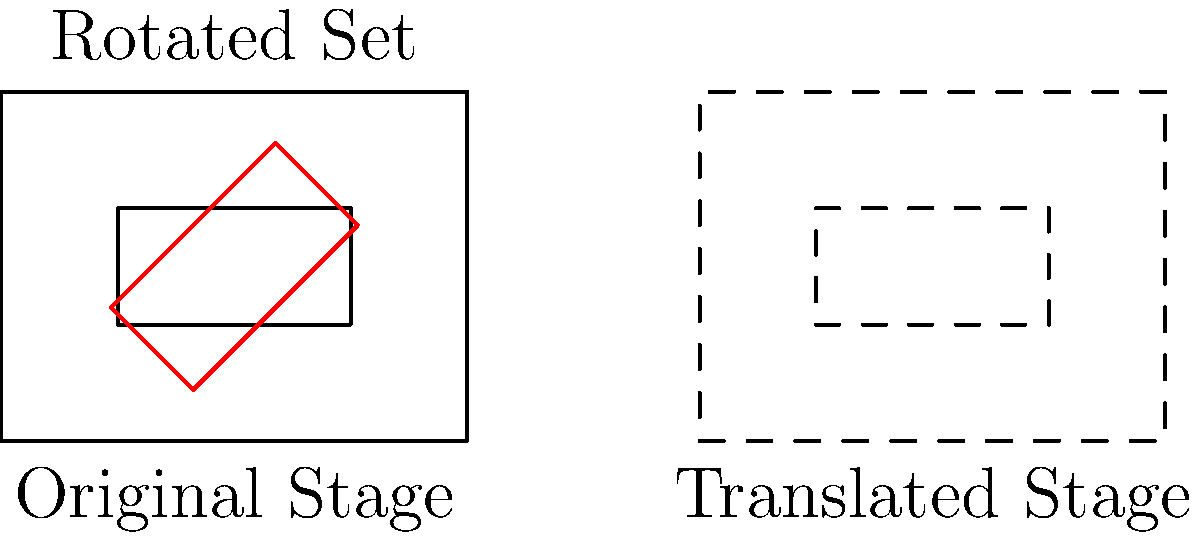In your latest theater production, you're working on a innovative stage design. The rectangular stage (represented by the outer rectangle) measures 4 units wide and 3 units high. Within it, there's a smaller rectangular set piece (the inner rectangle) that's initially positioned as shown. The stage manager wants to apply the following transformations:

1. Translate the entire stage layout 6 units to the right (shown with dashed lines).
2. Rotate the inner set piece 45 degrees clockwise around its center point.

After these transformations, what is the approximate area of overlap between the rotated inner set piece (shown in red) and the translated outer stage? Let's approach this step-by-step:

1. Original dimensions:
   - Outer stage: 4 units × 3 units
   - Inner set piece: 2 units × 1 unit

2. Translation:
   - The entire layout is moved 6 units to the right.
   - This doesn't affect the overlap calculation.

3. Rotation:
   - The inner set piece is rotated 45° clockwise around its center.
   - This changes its orientation but not its area.

4. Overlap calculation:
   - The rotated set piece now forms a diamond shape inside the original stage area.
   - The corners of this diamond extend beyond the original set piece's boundaries.
   - However, parts of the rotated set still remain within the original stage.

5. Approximating the overlap:
   - The overlap forms irregular shapes at the corners of the rotated set.
   - We can estimate that about 3/4 of the rotated set remains within the original stage boundaries.
   - Area of the inner set = 2 × 1 = 2 square units
   - Approximate overlap area = 3/4 × 2 = 1.5 square units

Therefore, the approximate area of overlap between the rotated inner set piece and the translated outer stage is about 1.5 square units.
Answer: Approximately 1.5 square units 